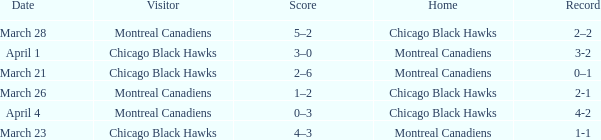Which home team has a record of 3-2? Montreal Canadiens. 